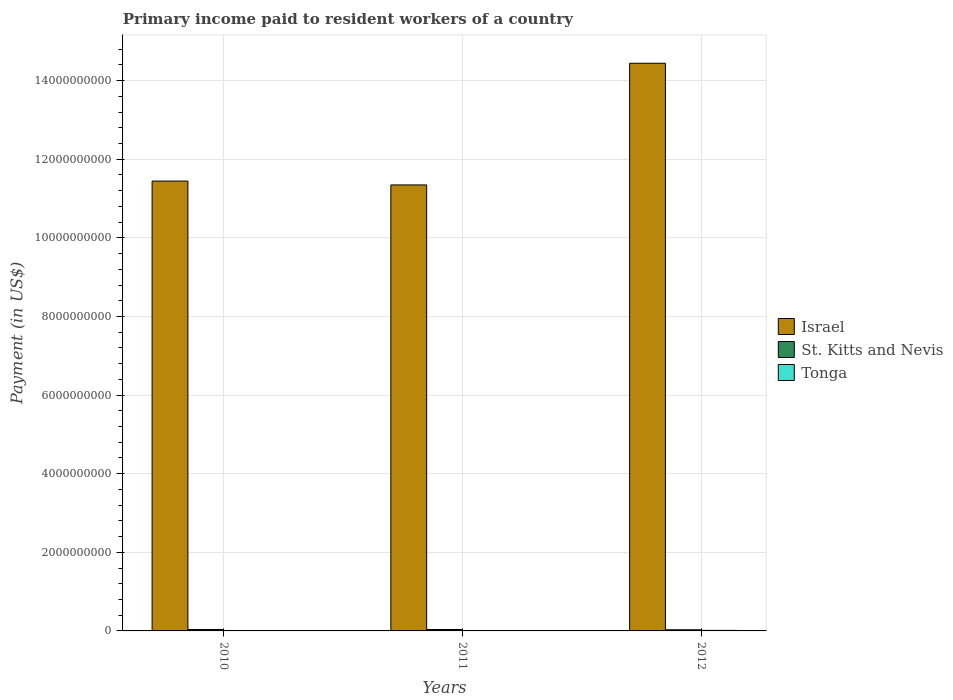How many groups of bars are there?
Ensure brevity in your answer.  3. Are the number of bars per tick equal to the number of legend labels?
Offer a terse response. Yes. How many bars are there on the 2nd tick from the right?
Offer a terse response. 3. What is the amount paid to workers in St. Kitts and Nevis in 2010?
Make the answer very short. 3.69e+07. Across all years, what is the maximum amount paid to workers in St. Kitts and Nevis?
Your answer should be very brief. 3.69e+07. Across all years, what is the minimum amount paid to workers in Israel?
Keep it short and to the point. 1.13e+1. In which year was the amount paid to workers in Tonga minimum?
Ensure brevity in your answer.  2010. What is the total amount paid to workers in St. Kitts and Nevis in the graph?
Give a very brief answer. 1.02e+08. What is the difference between the amount paid to workers in Tonga in 2010 and that in 2011?
Provide a succinct answer. -4.31e+06. What is the difference between the amount paid to workers in Israel in 2010 and the amount paid to workers in St. Kitts and Nevis in 2012?
Ensure brevity in your answer.  1.14e+1. What is the average amount paid to workers in Israel per year?
Ensure brevity in your answer.  1.24e+1. In the year 2011, what is the difference between the amount paid to workers in Israel and amount paid to workers in Tonga?
Provide a short and direct response. 1.13e+1. What is the ratio of the amount paid to workers in St. Kitts and Nevis in 2011 to that in 2012?
Keep it short and to the point. 1.24. Is the difference between the amount paid to workers in Israel in 2010 and 2012 greater than the difference between the amount paid to workers in Tonga in 2010 and 2012?
Give a very brief answer. No. What is the difference between the highest and the second highest amount paid to workers in St. Kitts and Nevis?
Give a very brief answer. 8.65e+05. What is the difference between the highest and the lowest amount paid to workers in Israel?
Your answer should be very brief. 3.10e+09. Is the sum of the amount paid to workers in St. Kitts and Nevis in 2010 and 2012 greater than the maximum amount paid to workers in Israel across all years?
Provide a short and direct response. No. What does the 1st bar from the left in 2010 represents?
Keep it short and to the point. Israel. What does the 1st bar from the right in 2010 represents?
Your answer should be very brief. Tonga. Is it the case that in every year, the sum of the amount paid to workers in St. Kitts and Nevis and amount paid to workers in Tonga is greater than the amount paid to workers in Israel?
Your response must be concise. No. Are all the bars in the graph horizontal?
Provide a short and direct response. No. How many years are there in the graph?
Your response must be concise. 3. What is the difference between two consecutive major ticks on the Y-axis?
Offer a very short reply. 2.00e+09. Are the values on the major ticks of Y-axis written in scientific E-notation?
Give a very brief answer. No. Does the graph contain grids?
Give a very brief answer. Yes. Where does the legend appear in the graph?
Give a very brief answer. Center right. How many legend labels are there?
Your answer should be very brief. 3. What is the title of the graph?
Make the answer very short. Primary income paid to resident workers of a country. Does "Chad" appear as one of the legend labels in the graph?
Keep it short and to the point. No. What is the label or title of the X-axis?
Keep it short and to the point. Years. What is the label or title of the Y-axis?
Offer a very short reply. Payment (in US$). What is the Payment (in US$) of Israel in 2010?
Make the answer very short. 1.14e+1. What is the Payment (in US$) in St. Kitts and Nevis in 2010?
Your answer should be compact. 3.69e+07. What is the Payment (in US$) of Tonga in 2010?
Keep it short and to the point. 5.32e+06. What is the Payment (in US$) of Israel in 2011?
Your response must be concise. 1.13e+1. What is the Payment (in US$) of St. Kitts and Nevis in 2011?
Keep it short and to the point. 3.60e+07. What is the Payment (in US$) in Tonga in 2011?
Your answer should be compact. 9.63e+06. What is the Payment (in US$) in Israel in 2012?
Offer a terse response. 1.44e+1. What is the Payment (in US$) in St. Kitts and Nevis in 2012?
Ensure brevity in your answer.  2.91e+07. What is the Payment (in US$) in Tonga in 2012?
Ensure brevity in your answer.  1.40e+07. Across all years, what is the maximum Payment (in US$) of Israel?
Your response must be concise. 1.44e+1. Across all years, what is the maximum Payment (in US$) in St. Kitts and Nevis?
Make the answer very short. 3.69e+07. Across all years, what is the maximum Payment (in US$) in Tonga?
Provide a succinct answer. 1.40e+07. Across all years, what is the minimum Payment (in US$) of Israel?
Provide a succinct answer. 1.13e+1. Across all years, what is the minimum Payment (in US$) of St. Kitts and Nevis?
Ensure brevity in your answer.  2.91e+07. Across all years, what is the minimum Payment (in US$) in Tonga?
Ensure brevity in your answer.  5.32e+06. What is the total Payment (in US$) in Israel in the graph?
Give a very brief answer. 3.72e+1. What is the total Payment (in US$) of St. Kitts and Nevis in the graph?
Offer a very short reply. 1.02e+08. What is the total Payment (in US$) in Tonga in the graph?
Provide a short and direct response. 2.89e+07. What is the difference between the Payment (in US$) of Israel in 2010 and that in 2011?
Your answer should be very brief. 9.83e+07. What is the difference between the Payment (in US$) in St. Kitts and Nevis in 2010 and that in 2011?
Offer a very short reply. 8.65e+05. What is the difference between the Payment (in US$) of Tonga in 2010 and that in 2011?
Give a very brief answer. -4.31e+06. What is the difference between the Payment (in US$) in Israel in 2010 and that in 2012?
Your answer should be compact. -3.00e+09. What is the difference between the Payment (in US$) in St. Kitts and Nevis in 2010 and that in 2012?
Your answer should be very brief. 7.81e+06. What is the difference between the Payment (in US$) in Tonga in 2010 and that in 2012?
Give a very brief answer. -8.65e+06. What is the difference between the Payment (in US$) of Israel in 2011 and that in 2012?
Make the answer very short. -3.10e+09. What is the difference between the Payment (in US$) in St. Kitts and Nevis in 2011 and that in 2012?
Provide a short and direct response. 6.94e+06. What is the difference between the Payment (in US$) in Tonga in 2011 and that in 2012?
Your answer should be compact. -4.34e+06. What is the difference between the Payment (in US$) in Israel in 2010 and the Payment (in US$) in St. Kitts and Nevis in 2011?
Give a very brief answer. 1.14e+1. What is the difference between the Payment (in US$) in Israel in 2010 and the Payment (in US$) in Tonga in 2011?
Provide a succinct answer. 1.14e+1. What is the difference between the Payment (in US$) in St. Kitts and Nevis in 2010 and the Payment (in US$) in Tonga in 2011?
Make the answer very short. 2.73e+07. What is the difference between the Payment (in US$) of Israel in 2010 and the Payment (in US$) of St. Kitts and Nevis in 2012?
Offer a very short reply. 1.14e+1. What is the difference between the Payment (in US$) of Israel in 2010 and the Payment (in US$) of Tonga in 2012?
Provide a short and direct response. 1.14e+1. What is the difference between the Payment (in US$) in St. Kitts and Nevis in 2010 and the Payment (in US$) in Tonga in 2012?
Keep it short and to the point. 2.29e+07. What is the difference between the Payment (in US$) in Israel in 2011 and the Payment (in US$) in St. Kitts and Nevis in 2012?
Offer a very short reply. 1.13e+1. What is the difference between the Payment (in US$) of Israel in 2011 and the Payment (in US$) of Tonga in 2012?
Make the answer very short. 1.13e+1. What is the difference between the Payment (in US$) in St. Kitts and Nevis in 2011 and the Payment (in US$) in Tonga in 2012?
Ensure brevity in your answer.  2.21e+07. What is the average Payment (in US$) of Israel per year?
Offer a terse response. 1.24e+1. What is the average Payment (in US$) of St. Kitts and Nevis per year?
Your response must be concise. 3.40e+07. What is the average Payment (in US$) in Tonga per year?
Your answer should be compact. 9.64e+06. In the year 2010, what is the difference between the Payment (in US$) in Israel and Payment (in US$) in St. Kitts and Nevis?
Your answer should be very brief. 1.14e+1. In the year 2010, what is the difference between the Payment (in US$) of Israel and Payment (in US$) of Tonga?
Your answer should be very brief. 1.14e+1. In the year 2010, what is the difference between the Payment (in US$) in St. Kitts and Nevis and Payment (in US$) in Tonga?
Keep it short and to the point. 3.16e+07. In the year 2011, what is the difference between the Payment (in US$) in Israel and Payment (in US$) in St. Kitts and Nevis?
Provide a short and direct response. 1.13e+1. In the year 2011, what is the difference between the Payment (in US$) of Israel and Payment (in US$) of Tonga?
Ensure brevity in your answer.  1.13e+1. In the year 2011, what is the difference between the Payment (in US$) in St. Kitts and Nevis and Payment (in US$) in Tonga?
Your answer should be very brief. 2.64e+07. In the year 2012, what is the difference between the Payment (in US$) of Israel and Payment (in US$) of St. Kitts and Nevis?
Your answer should be compact. 1.44e+1. In the year 2012, what is the difference between the Payment (in US$) of Israel and Payment (in US$) of Tonga?
Keep it short and to the point. 1.44e+1. In the year 2012, what is the difference between the Payment (in US$) of St. Kitts and Nevis and Payment (in US$) of Tonga?
Offer a very short reply. 1.51e+07. What is the ratio of the Payment (in US$) of Israel in 2010 to that in 2011?
Offer a terse response. 1.01. What is the ratio of the Payment (in US$) in Tonga in 2010 to that in 2011?
Offer a terse response. 0.55. What is the ratio of the Payment (in US$) of Israel in 2010 to that in 2012?
Your answer should be compact. 0.79. What is the ratio of the Payment (in US$) in St. Kitts and Nevis in 2010 to that in 2012?
Your response must be concise. 1.27. What is the ratio of the Payment (in US$) of Tonga in 2010 to that in 2012?
Your response must be concise. 0.38. What is the ratio of the Payment (in US$) in Israel in 2011 to that in 2012?
Give a very brief answer. 0.79. What is the ratio of the Payment (in US$) of St. Kitts and Nevis in 2011 to that in 2012?
Your answer should be very brief. 1.24. What is the ratio of the Payment (in US$) in Tonga in 2011 to that in 2012?
Your response must be concise. 0.69. What is the difference between the highest and the second highest Payment (in US$) of Israel?
Your response must be concise. 3.00e+09. What is the difference between the highest and the second highest Payment (in US$) of St. Kitts and Nevis?
Offer a terse response. 8.65e+05. What is the difference between the highest and the second highest Payment (in US$) of Tonga?
Offer a very short reply. 4.34e+06. What is the difference between the highest and the lowest Payment (in US$) in Israel?
Make the answer very short. 3.10e+09. What is the difference between the highest and the lowest Payment (in US$) in St. Kitts and Nevis?
Your response must be concise. 7.81e+06. What is the difference between the highest and the lowest Payment (in US$) in Tonga?
Ensure brevity in your answer.  8.65e+06. 